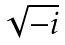Convert formula to latex. <formula><loc_0><loc_0><loc_500><loc_500>\sqrt { - i }</formula> 